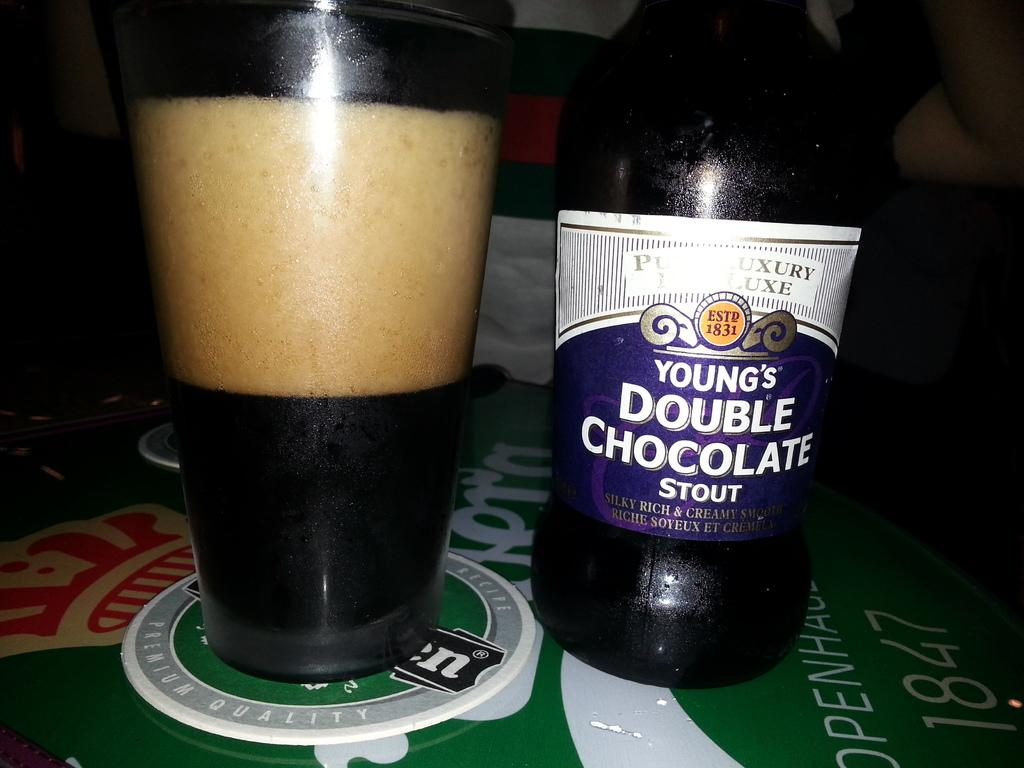<image>
Render a clear and concise summary of the photo. Bottle of Young Double Chocolate Stout next to a cup of beer. 